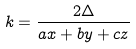<formula> <loc_0><loc_0><loc_500><loc_500>k = \frac { 2 \Delta } { a x + b y + c z }</formula> 